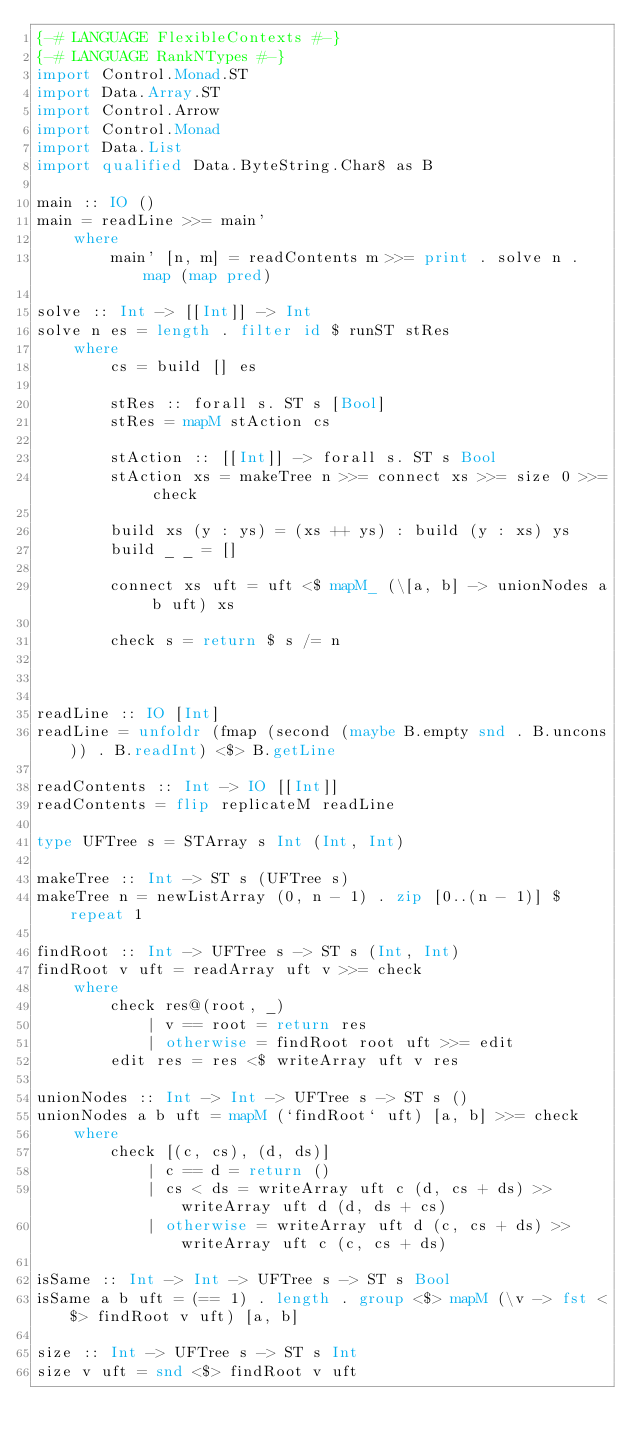<code> <loc_0><loc_0><loc_500><loc_500><_Haskell_>{-# LANGUAGE FlexibleContexts #-}
{-# LANGUAGE RankNTypes #-}
import Control.Monad.ST
import Data.Array.ST
import Control.Arrow
import Control.Monad
import Data.List
import qualified Data.ByteString.Char8 as B

main :: IO ()
main = readLine >>= main'
    where
        main' [n, m] = readContents m >>= print . solve n . map (map pred)

solve :: Int -> [[Int]] -> Int
solve n es = length . filter id $ runST stRes
    where
        cs = build [] es

        stRes :: forall s. ST s [Bool]
        stRes = mapM stAction cs

        stAction :: [[Int]] -> forall s. ST s Bool
        stAction xs = makeTree n >>= connect xs >>= size 0 >>= check 

        build xs (y : ys) = (xs ++ ys) : build (y : xs) ys
        build _ _ = []

        connect xs uft = uft <$ mapM_ (\[a, b] -> unionNodes a b uft) xs 

        check s = return $ s /= n

                

readLine :: IO [Int]
readLine = unfoldr (fmap (second (maybe B.empty snd . B.uncons)) . B.readInt) <$> B.getLine

readContents :: Int -> IO [[Int]]
readContents = flip replicateM readLine

type UFTree s = STArray s Int (Int, Int)

makeTree :: Int -> ST s (UFTree s)
makeTree n = newListArray (0, n - 1) . zip [0..(n - 1)] $ repeat 1

findRoot :: Int -> UFTree s -> ST s (Int, Int)
findRoot v uft = readArray uft v >>= check
    where
        check res@(root, _)
            | v == root = return res
            | otherwise = findRoot root uft >>= edit
        edit res = res <$ writeArray uft v res
            
unionNodes :: Int -> Int -> UFTree s -> ST s ()
unionNodes a b uft = mapM (`findRoot` uft) [a, b] >>= check
    where
        check [(c, cs), (d, ds)]
            | c == d = return ()
            | cs < ds = writeArray uft c (d, cs + ds) >> writeArray uft d (d, ds + cs)
            | otherwise = writeArray uft d (c, cs + ds) >> writeArray uft c (c, cs + ds) 

isSame :: Int -> Int -> UFTree s -> ST s Bool
isSame a b uft = (== 1) . length . group <$> mapM (\v -> fst <$> findRoot v uft) [a, b]

size :: Int -> UFTree s -> ST s Int 
size v uft = snd <$> findRoot v uft</code> 